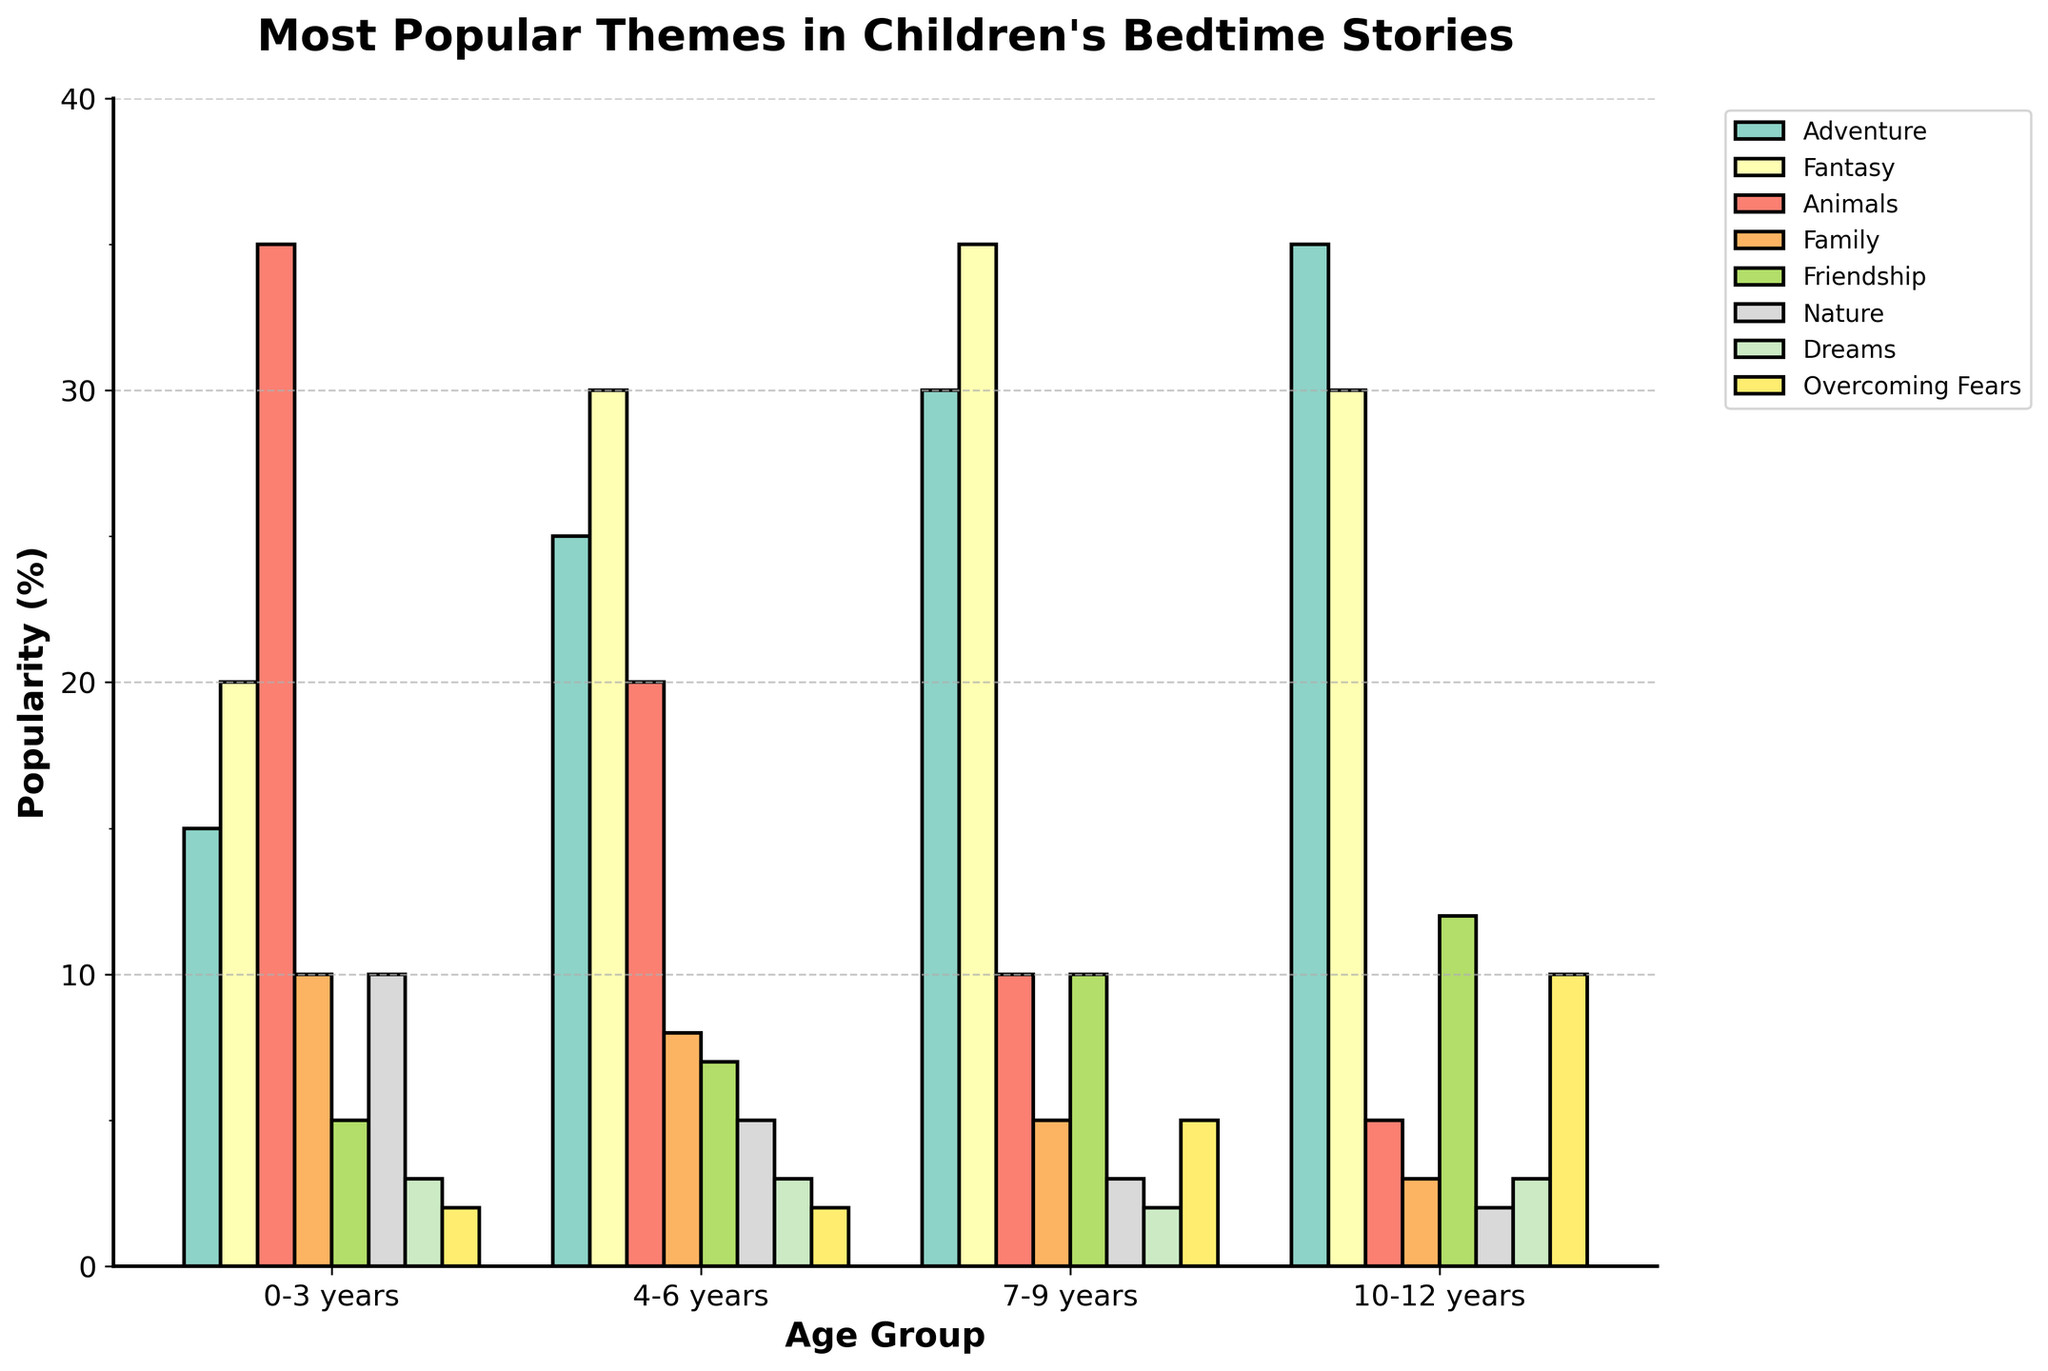Which theme is the most popular for children aged 0-3 years? Observe the bar corresponding to the age group 0-3 years. The bar representing the theme "Animals" has the highest value at 35%.
Answer: Animals How does the popularity of "Fantasy" stories change as children get older? Examine the bars for the theme "Fantasy" across different age groups. The popularity increases from 20% at 0-3 years, to 30% at 4-6 years, reaches a peak at 35% for 7-9 years, and then decreases slightly to 30% for 10-12 years.
Answer: Increases, peaks, then slightly decreases Which age group has the highest preference for "Overcoming Fears" themes? Look at the bars for the theme "Overcoming Fears". The height is greatest for the age group 10-12 years at 10%.
Answer: 10-12 years What is the difference in the popularity of "Adventure" stories between the youngest and oldest age groups? Compare the height of the bars for the theme "Adventure" between age groups 0-3 years (15%) and 10-12 years (35%). The difference is 35% - 15% = 20%.
Answer: 20% Is the theme "Friendship" more popular for children aged 4-6 years or 7-9 years? Compare the height of the bars for the theme "Friendship" between the age groups 4-6 years (7%) and 7-9 years (10%).
Answer: 7-9 years Which theme remains consistently unpopular across all age groups? Observe all bars across different themes and age groups. The theme "Dreams" has consistently low values, with bars at 3%, 3%, 2%, and 3% across all age groups.
Answer: Dreams What is the combined popularity of the "Nature" theme for all age groups? Sum the percentages for the theme "Nature" across all age groups: 10% (0-3 years) + 5% (4-6 years) + 3% (7-9 years) + 2% (10-12 years) = 20%.
Answer: 20% How much more popular are "Animal" stories for 0-3 years compared to 10-12 years? Compare the values of the "Animals" theme for 0-3 years (35%) and 10-12 years (5%). The difference is 35% - 5% = 30%.
Answer: 30% In which age group is the theme "Family" at its lowest popularity? Observe the bars for the theme "Family" across different age groups. The lowest value is for 10-12 years at 3%.
Answer: 10-12 years 